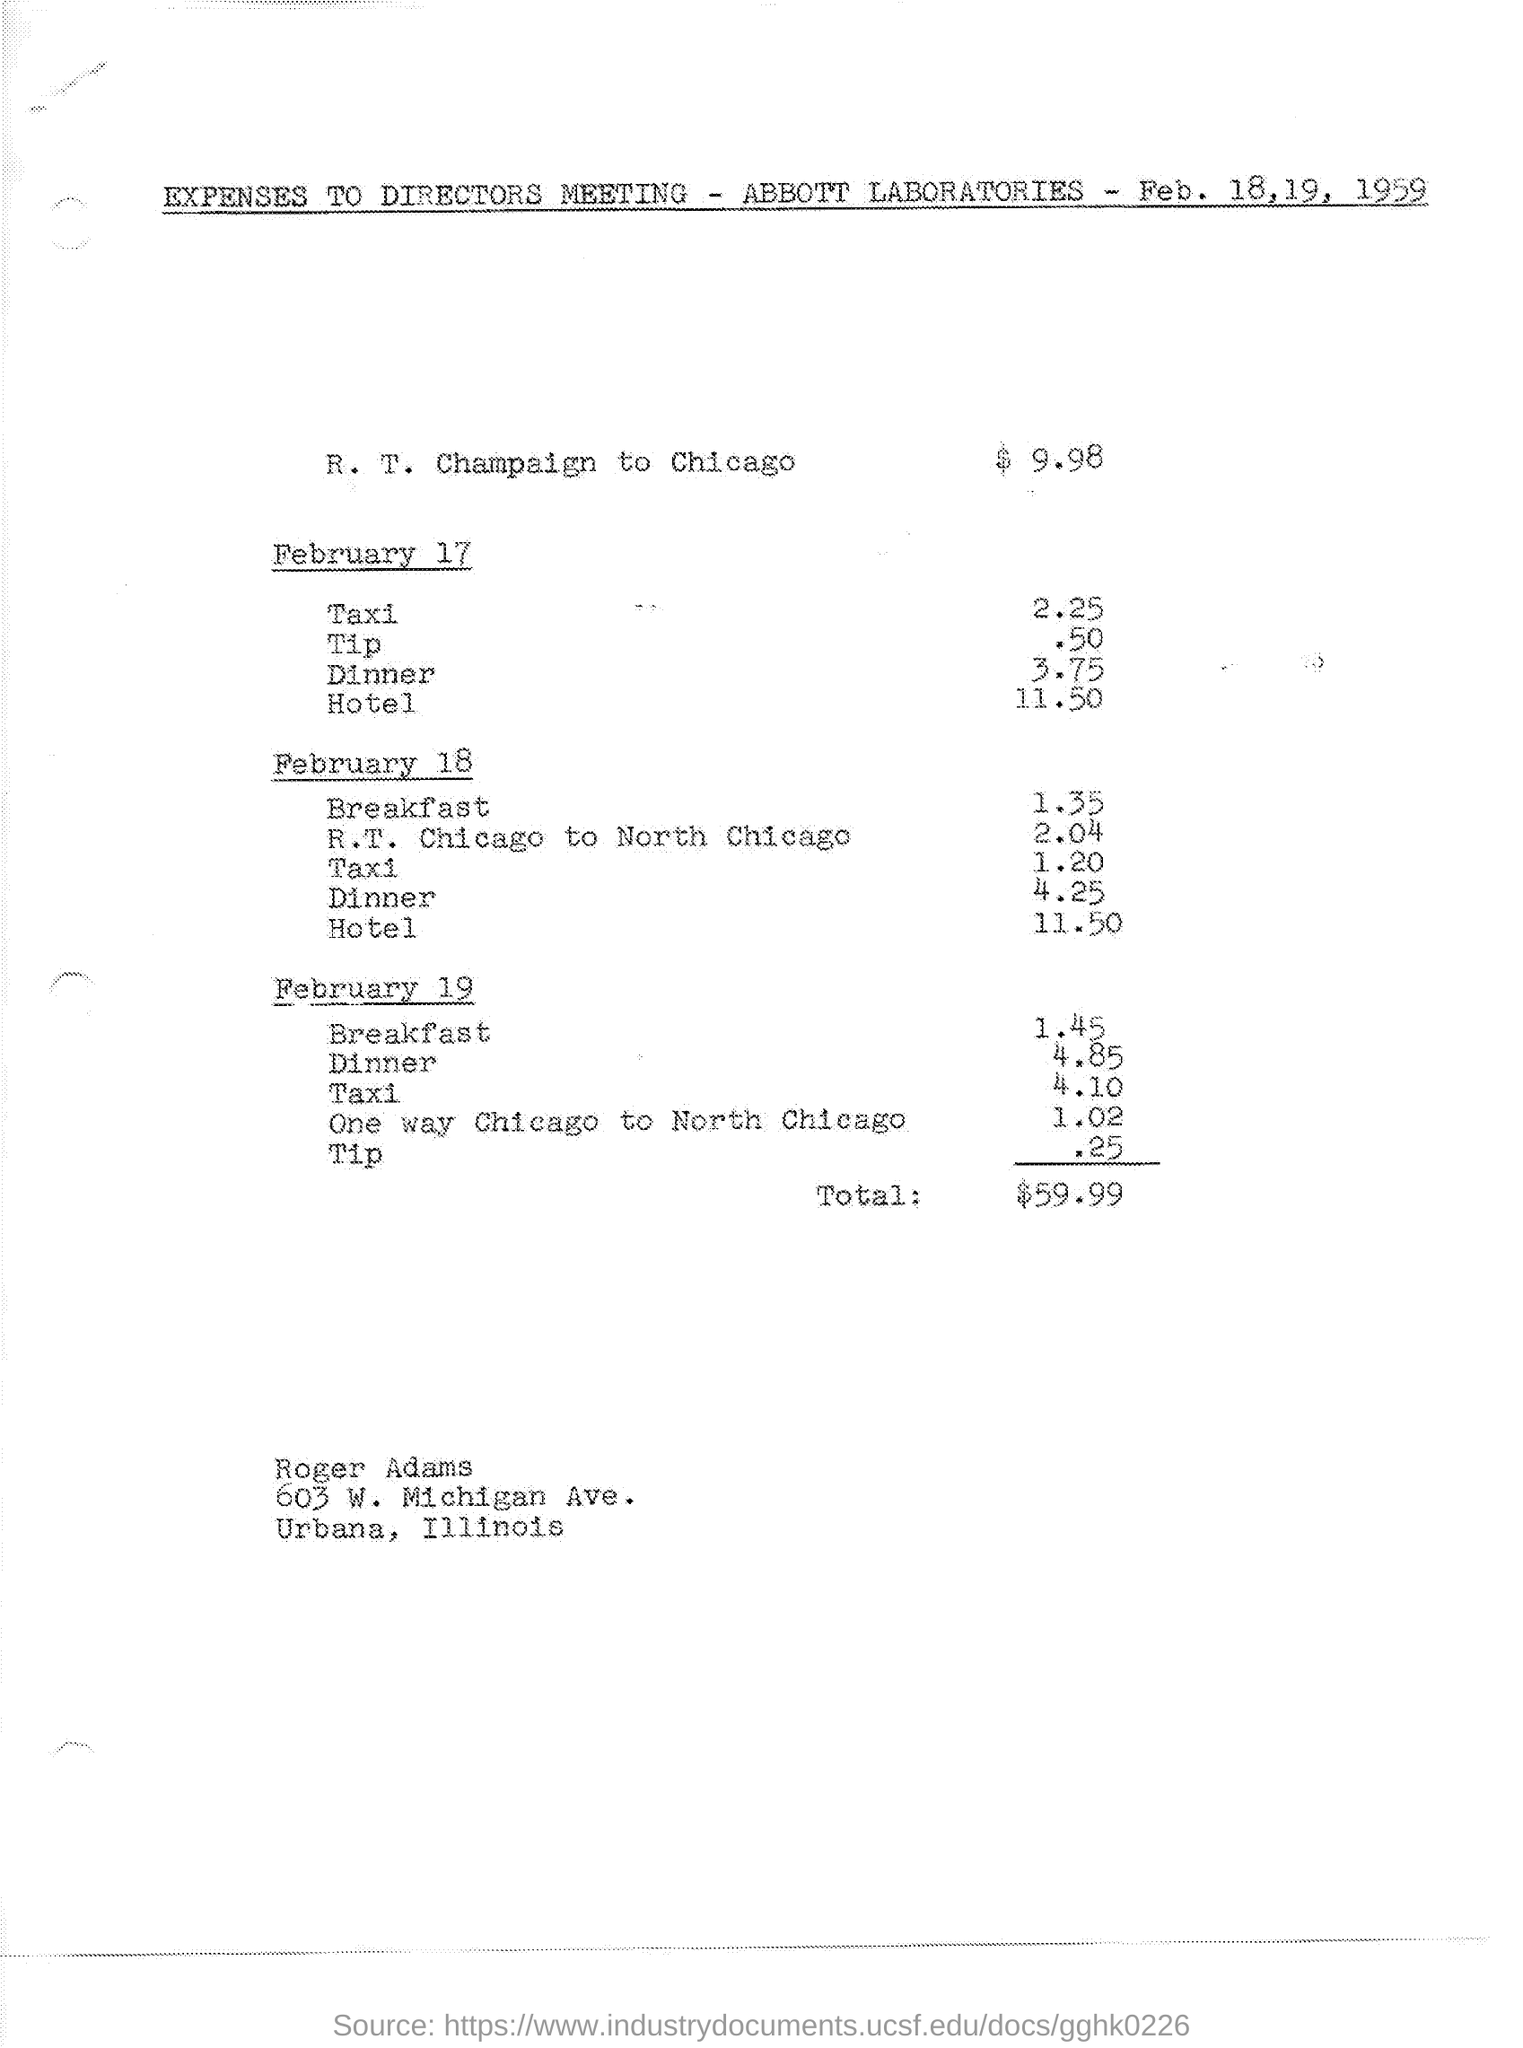What are the expenses for r.t. champaign to chicago ?
Ensure brevity in your answer.  $9.98. What are the expenses for taxi on february 17 ?
Keep it short and to the point. 2.25. What are the expenses for dinner on february 17 ?
Give a very brief answer. 3 75. What are the expenses for hotel on february 17 ?
Your answer should be very brief. 11 50. What are the expenses for breakfast on february 18 ?
Make the answer very short. 1.35. What are the expenses for dinner on february 18 ?
Ensure brevity in your answer.  4 25. What is the cost of hotel on february 18 ?
Offer a terse response. 11 50. What is the cost of taxi on february 18 ?
Offer a terse response. 1.20. What is the cost for one way chicago to north chicago on february 19 ?
Offer a very short reply. 1 02. What are the total expenses mentioned in the given page ?
Keep it short and to the point. $ 59.99. 